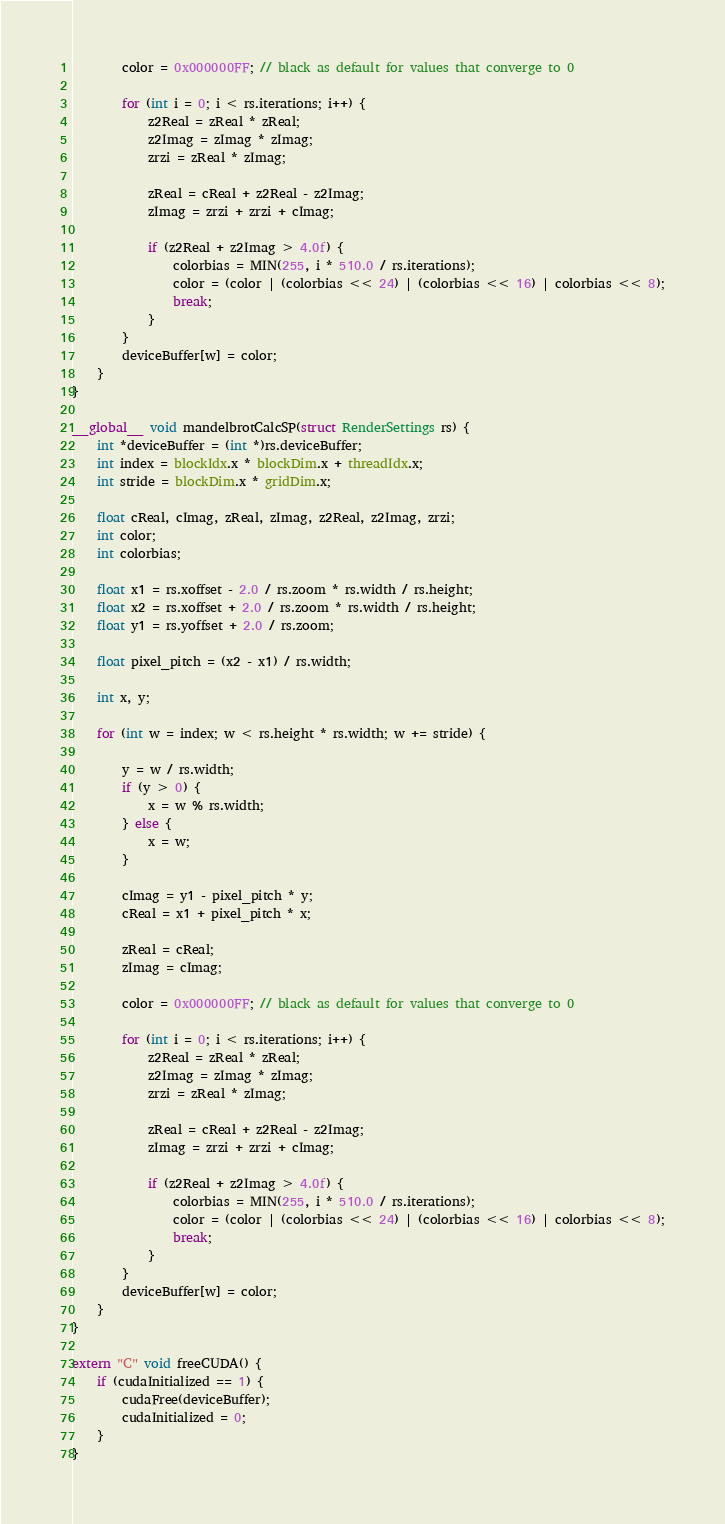<code> <loc_0><loc_0><loc_500><loc_500><_Cuda_>
        color = 0x000000FF; // black as default for values that converge to 0

        for (int i = 0; i < rs.iterations; i++) {
            z2Real = zReal * zReal;
            z2Imag = zImag * zImag;
            zrzi = zReal * zImag;

            zReal = cReal + z2Real - z2Imag;
            zImag = zrzi + zrzi + cImag;

            if (z2Real + z2Imag > 4.0f) {
                colorbias = MIN(255, i * 510.0 / rs.iterations);
                color = (color | (colorbias << 24) | (colorbias << 16) | colorbias << 8);
                break;
            }
        }
        deviceBuffer[w] = color;
    }
}

__global__ void mandelbrotCalcSP(struct RenderSettings rs) {
    int *deviceBuffer = (int *)rs.deviceBuffer;
    int index = blockIdx.x * blockDim.x + threadIdx.x;
    int stride = blockDim.x * gridDim.x;

    float cReal, cImag, zReal, zImag, z2Real, z2Imag, zrzi;
    int color;
    int colorbias;

    float x1 = rs.xoffset - 2.0 / rs.zoom * rs.width / rs.height;
    float x2 = rs.xoffset + 2.0 / rs.zoom * rs.width / rs.height;
    float y1 = rs.yoffset + 2.0 / rs.zoom;

    float pixel_pitch = (x2 - x1) / rs.width;

    int x, y;

    for (int w = index; w < rs.height * rs.width; w += stride) {

        y = w / rs.width;
        if (y > 0) {
            x = w % rs.width;
        } else {
            x = w;
        }

        cImag = y1 - pixel_pitch * y;
        cReal = x1 + pixel_pitch * x;

        zReal = cReal;
        zImag = cImag;

        color = 0x000000FF; // black as default for values that converge to 0

        for (int i = 0; i < rs.iterations; i++) {
            z2Real = zReal * zReal;
            z2Imag = zImag * zImag;
            zrzi = zReal * zImag;

            zReal = cReal + z2Real - z2Imag;
            zImag = zrzi + zrzi + cImag;

            if (z2Real + z2Imag > 4.0f) {
                colorbias = MIN(255, i * 510.0 / rs.iterations);
                color = (color | (colorbias << 24) | (colorbias << 16) | colorbias << 8);
                break;
            }
        }
        deviceBuffer[w] = color;
    }
}

extern "C" void freeCUDA() {
    if (cudaInitialized == 1) {
        cudaFree(deviceBuffer);
        cudaInitialized = 0;
    }
}
</code> 